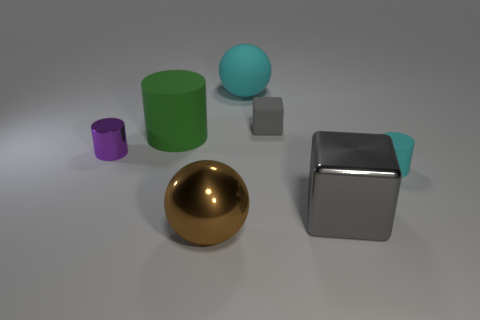What number of big objects are either rubber objects or green matte blocks?
Offer a very short reply. 2. Are there any cyan rubber balls that have the same size as the gray rubber thing?
Keep it short and to the point. No. There is a small cylinder to the right of the block that is behind the gray cube that is in front of the green thing; what is its color?
Provide a short and direct response. Cyan. Does the tiny gray cube have the same material as the large green thing that is on the right side of the purple object?
Your answer should be compact. Yes. There is a cyan thing that is the same shape as the tiny purple object; what is its size?
Offer a very short reply. Small. Are there an equal number of big rubber cylinders behind the green rubber cylinder and large cyan objects in front of the tiny cyan rubber thing?
Keep it short and to the point. Yes. What number of other things are made of the same material as the tiny gray block?
Provide a succinct answer. 3. Are there an equal number of cylinders in front of the small block and shiny things?
Give a very brief answer. Yes. There is a green object; is its size the same as the cube behind the gray shiny block?
Offer a terse response. No. What is the shape of the big thing that is right of the large rubber ball?
Keep it short and to the point. Cube. 